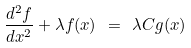Convert formula to latex. <formula><loc_0><loc_0><loc_500><loc_500>\frac { d ^ { 2 } f } { d x ^ { 2 } } + \lambda f ( x ) \ = \ \lambda C g ( x ) \</formula> 